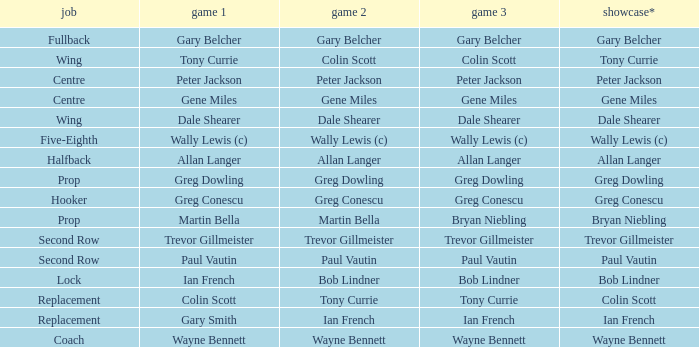What game 1 has halfback as a position? Allan Langer. 